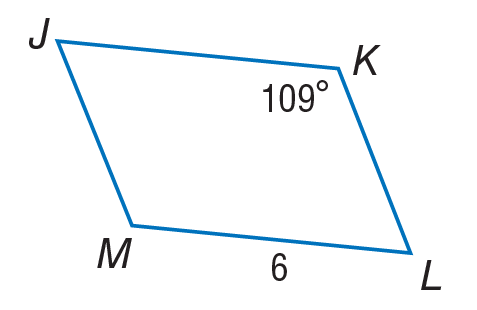Answer the mathemtical geometry problem and directly provide the correct option letter.
Question: Use parallelogram J K L M to find J K.
Choices: A: 4.5 B: 6 C: 10 D: 12 B 